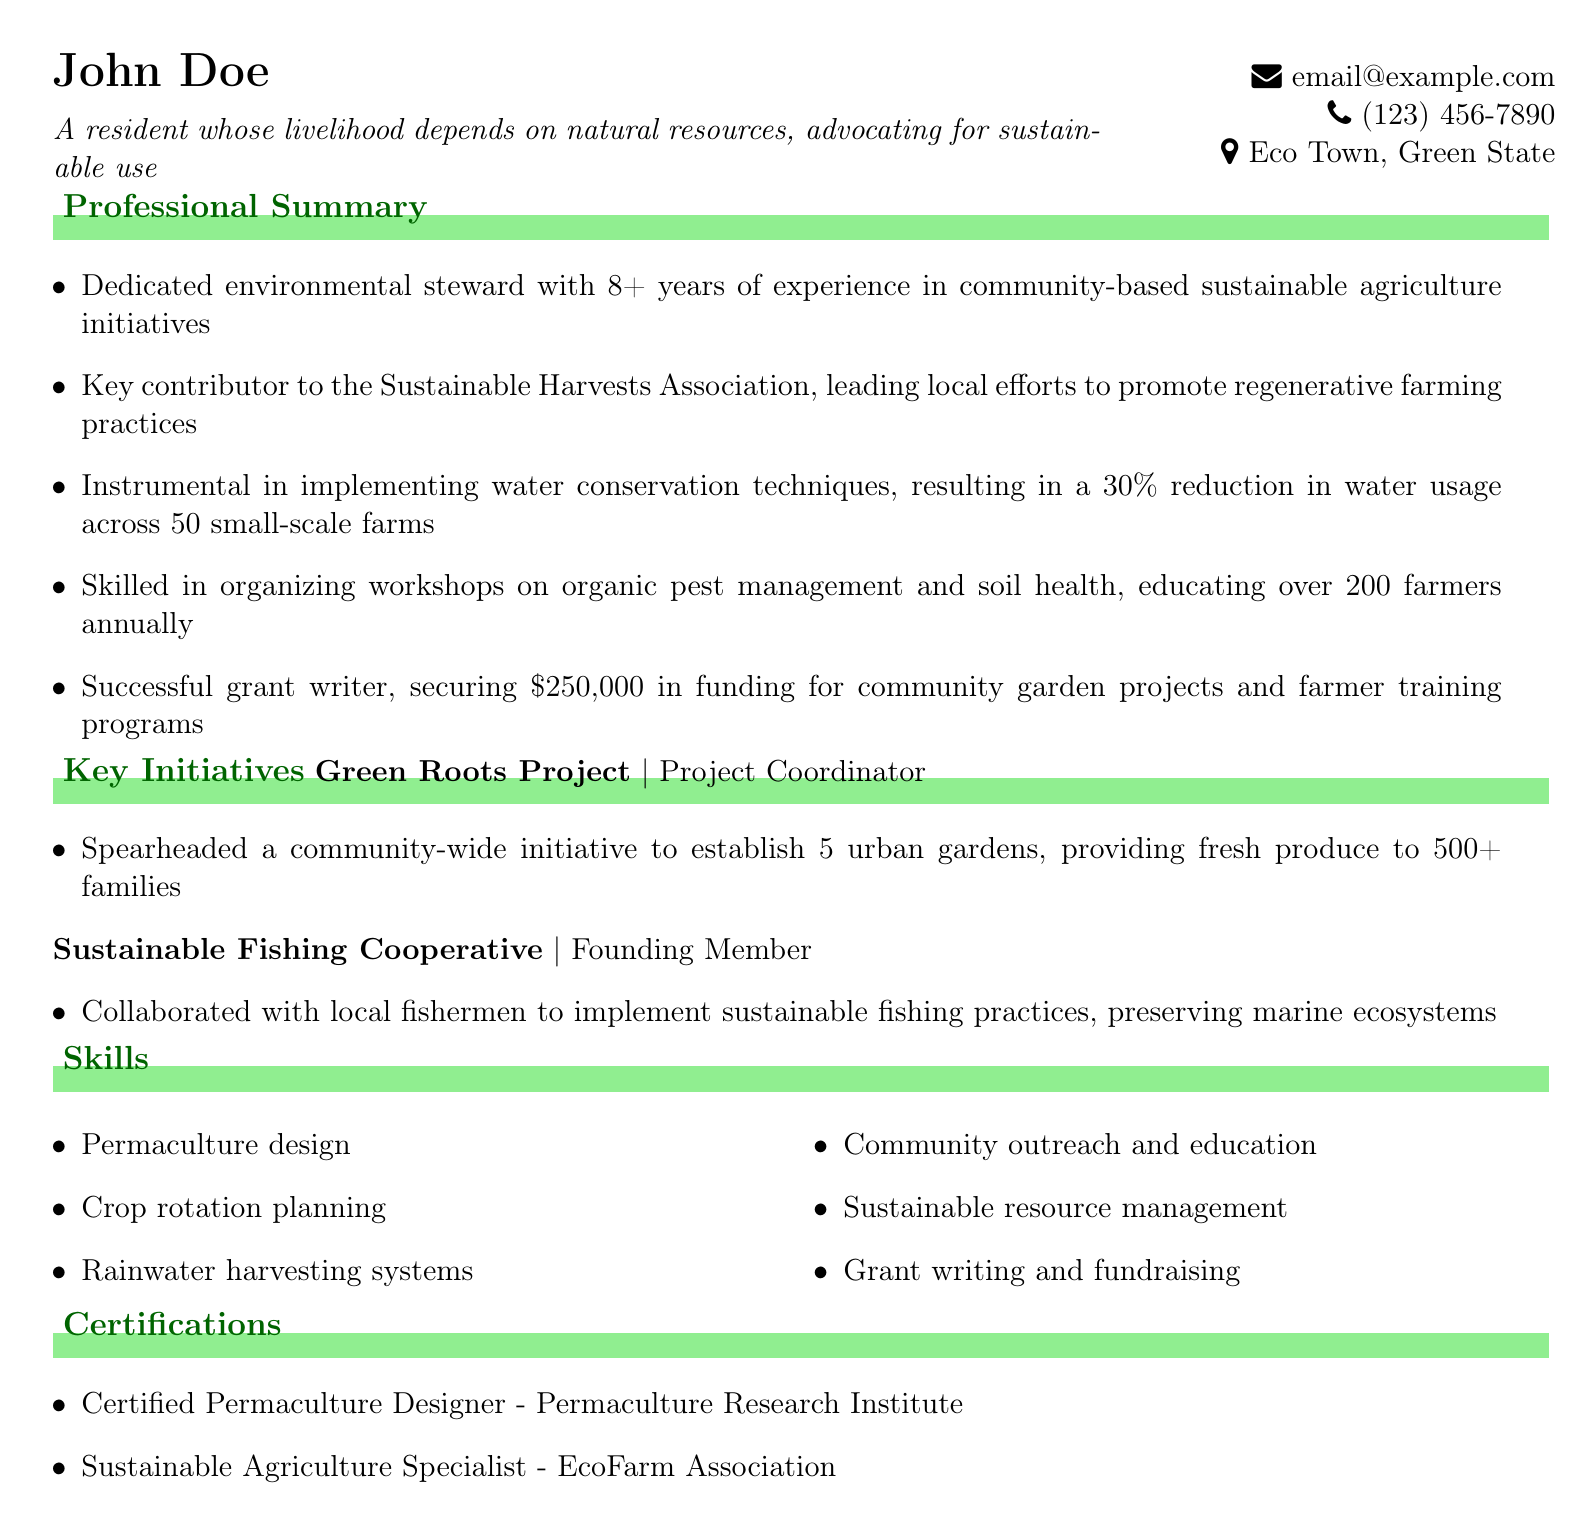What is the name of the organization mentioned in the professional summary? The organization mentioned is the Sustainable Harvests Association.
Answer: Sustainable Harvests Association How many years of experience does the individual have? The document states that the individual has 8+ years of experience.
Answer: 8+ years What percentage reduction in water usage was achieved? The professional summary mentions a 30% reduction in water usage.
Answer: 30% How many families benefited from the Green Roots Project? The Green Roots Project provided fresh produce to over 500 families.
Answer: 500+ What is one skill listed related to agriculture? The skills section highlights "Permaculture design" as one of the skills.
Answer: Permaculture design Which certification is obtained from the Permaculture Research Institute? The individual has the "Certified Permaculture Designer" certification.
Answer: Certified Permaculture Designer What role did the individual play in the Sustainable Fishing Cooperative? The individual was a "Founding Member" of the cooperative.
Answer: Founding Member How much funding was secured for community garden projects? The document mentions $250,000 secured for community garden projects.
Answer: $250,000 